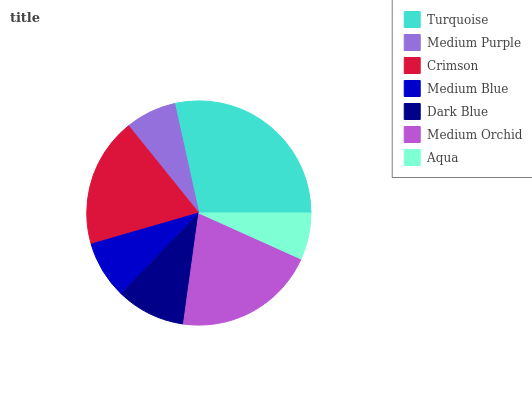Is Aqua the minimum?
Answer yes or no. Yes. Is Turquoise the maximum?
Answer yes or no. Yes. Is Medium Purple the minimum?
Answer yes or no. No. Is Medium Purple the maximum?
Answer yes or no. No. Is Turquoise greater than Medium Purple?
Answer yes or no. Yes. Is Medium Purple less than Turquoise?
Answer yes or no. Yes. Is Medium Purple greater than Turquoise?
Answer yes or no. No. Is Turquoise less than Medium Purple?
Answer yes or no. No. Is Dark Blue the high median?
Answer yes or no. Yes. Is Dark Blue the low median?
Answer yes or no. Yes. Is Crimson the high median?
Answer yes or no. No. Is Medium Orchid the low median?
Answer yes or no. No. 